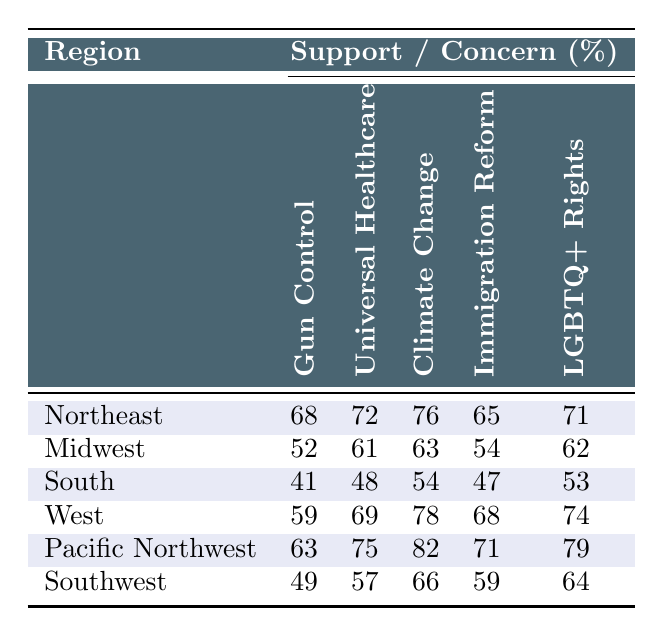What percentage of the Northeast supports gun control? The Northeast has a gun control support percentage listed as 68% in the table.
Answer: 68% Which region shows the highest support for universal healthcare? By examining the percentages, the Pacific Northwest has the highest support for universal healthcare at 75%.
Answer: Pacific Northwest What is the difference in climate change concern between the South and the West regions? The South has a climate change concern of 54%, while the West has 78%. The difference is 78 - 54 = 24.
Answer: 24% Is the support for LGBTQ+ rights in the Midwest higher than in the South? The Midwest has 62% support for LGBTQ+ rights, while the South has 53%. Since 62% is greater than 53%, the statement is true.
Answer: Yes What is the average support for immigration reform across all regions? Adding all the percentages: 65 + 54 + 47 + 68 + 71 + 59 = 364. Then divide by the number of regions (6): 364 / 6 = 60.67, which rounds to 61%.
Answer: 61% Which region is least concerned about climate change? By checking the percentages, the South has the lowest concern for climate change at 54%.
Answer: South What is the total support for gun control in the Northeast and Pacific Northwest combined? The Northeast supports gun control at 68% and the Pacific Northwest at 63%. Adding these gives 68 + 63 = 131%.
Answer: 131% Which issue has the most significant difference in support between the Northeast and the South? Analyzing the differences: Gun Control: 68 - 41 = 27, Universal Healthcare: 72 - 48 = 24, Climate Change: 76 - 54 = 22, Immigration Reform: 65 - 47 = 18, LGBTQ+ Rights: 71 - 53 = 18. The highest difference is for gun control at 27%.
Answer: Gun Control What percentage of the Midwest supports both gun control and climate change concern? The percentage supports in the Midwest for gun control is 52% and for climate change concern is 63%.
Answer: 52% and 63% Is there a region where support for universal healthcare is at least 70%? Yes, the Northeast (72%) and the Pacific Northwest (75%) both have support at least 70%.
Answer: Yes 